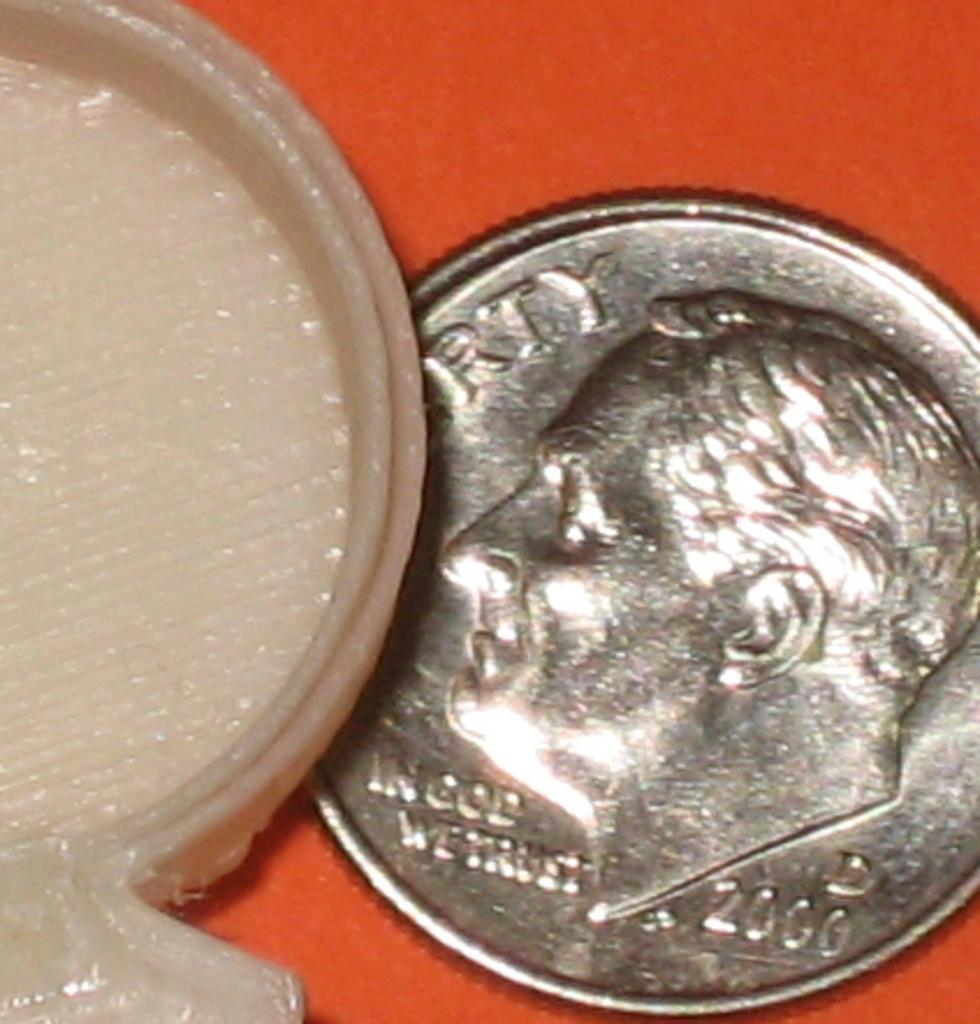What year is this dime?
Offer a terse response. 2000. What is the phrase on the coin?
Offer a terse response. In god we trust. 